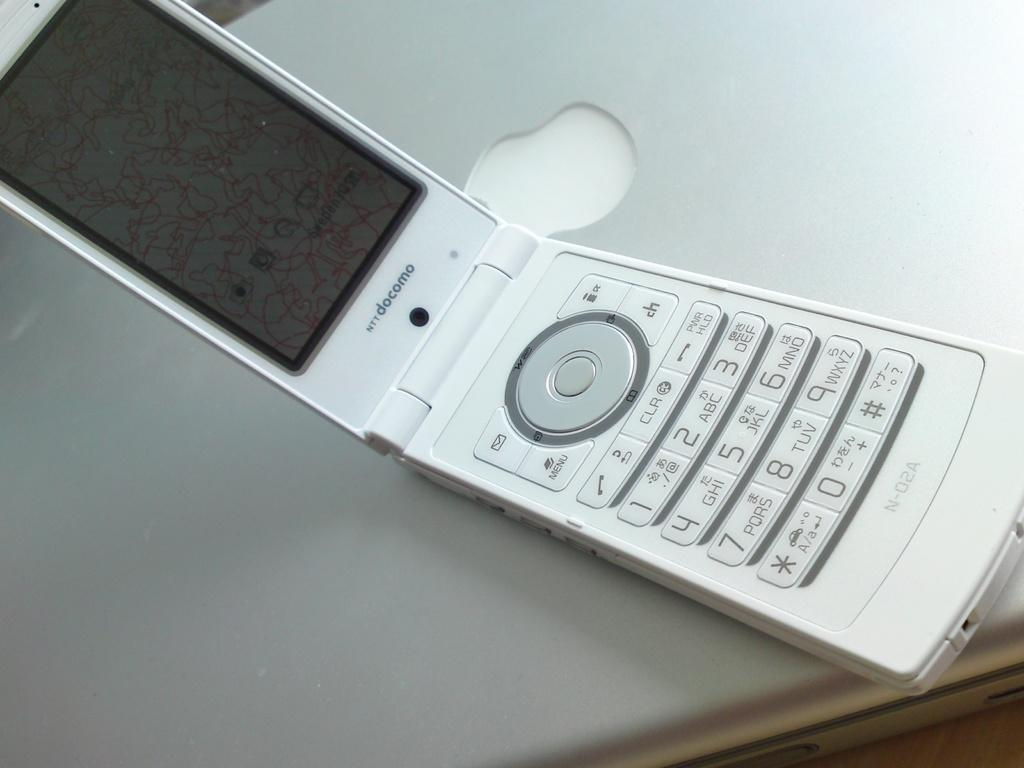<image>
Write a terse but informative summary of the picture. A flip phone that is open and has the words NTT docomo on it. 